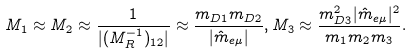Convert formula to latex. <formula><loc_0><loc_0><loc_500><loc_500>M _ { 1 } \approx M _ { 2 } \approx \frac { 1 } { | ( M _ { R } ^ { - 1 } ) _ { 1 2 } | } \approx \frac { m _ { D 1 } m _ { D 2 } } { | \hat { m } _ { e \mu } | } , M _ { 3 } \approx \frac { m _ { D 3 } ^ { 2 } | \hat { m } _ { e \mu } | ^ { 2 } } { m _ { 1 } m _ { 2 } m _ { 3 } } .</formula> 